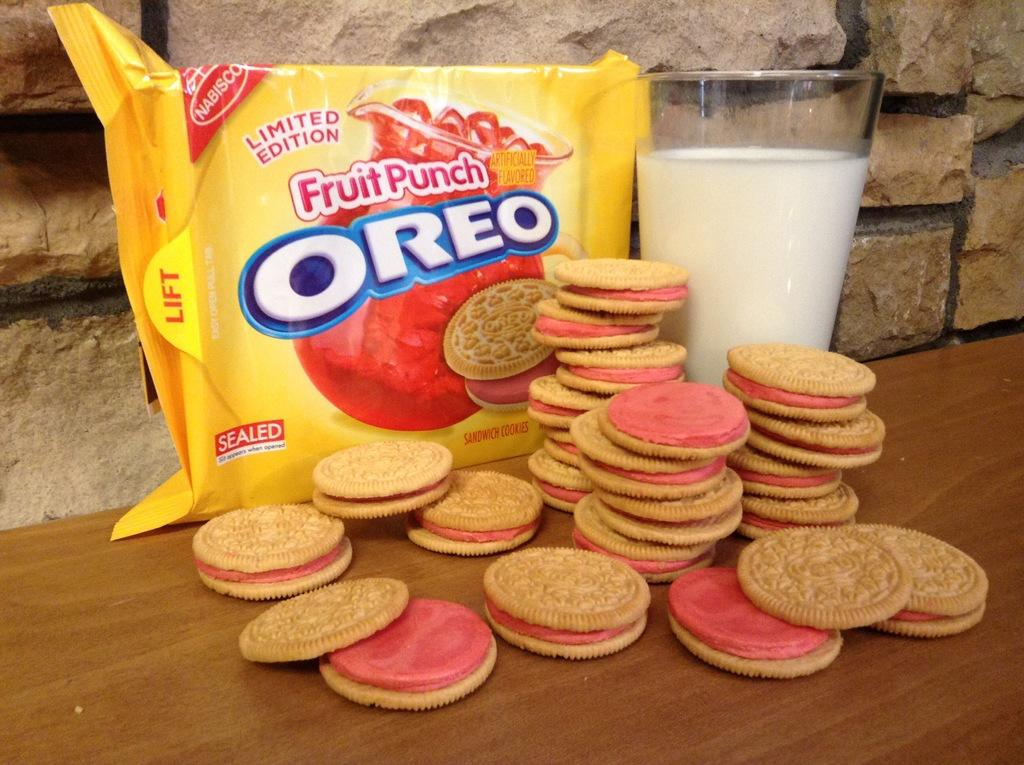What piece of furniture is present in the image? There is a table in the image. What type of food can be seen on the table? There are biscuits on the table. What else is on the table besides biscuits? There is a packet and a glass with milk on the table. What type of train is visible in the image? There is no train present in the image. Is there a crib or boot featured in the image? No, there is no crib or boot present in the image. 